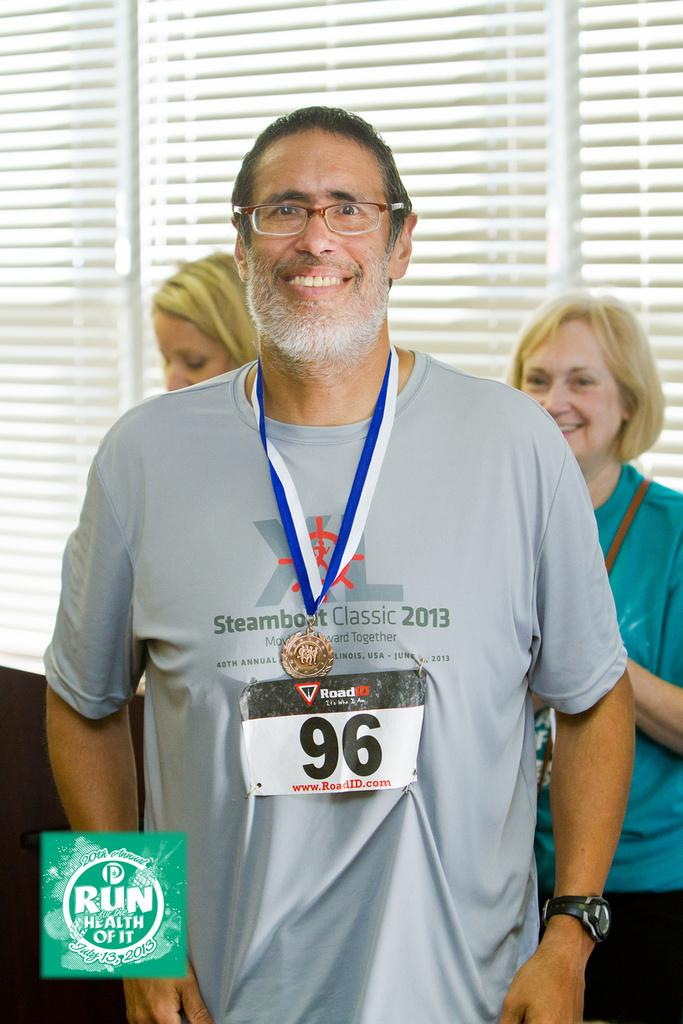<image>
Render a clear and concise summary of the photo. A man with a beard wears a grey top with Steamboat Classic 2013 and the number 96 on a lanyard. 